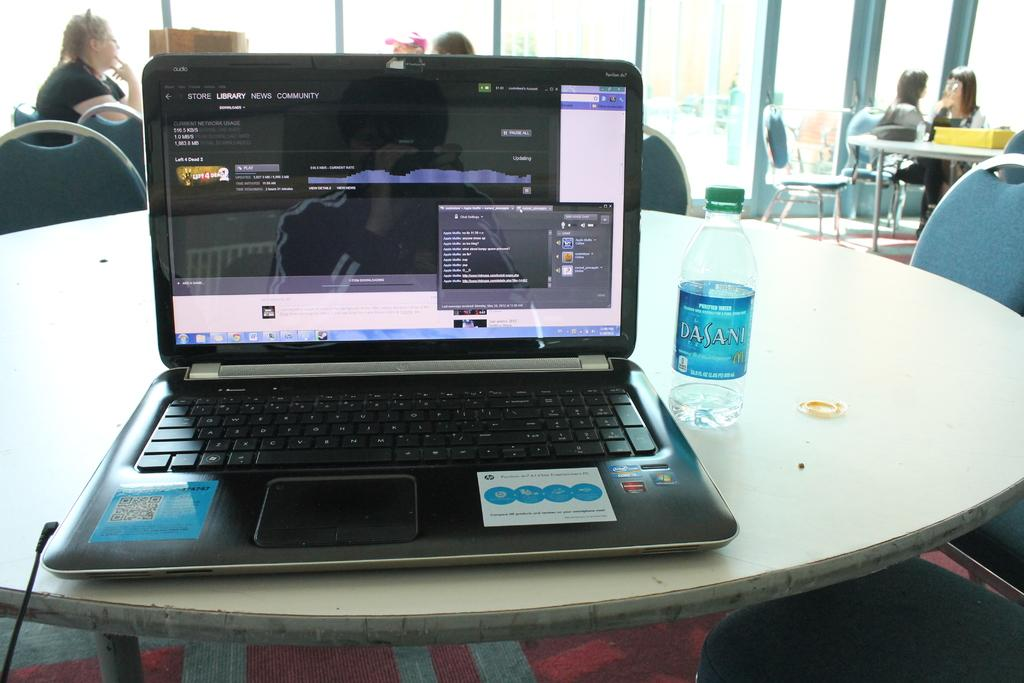<image>
Share a concise interpretation of the image provided. A laptop viewing an online community news website. 